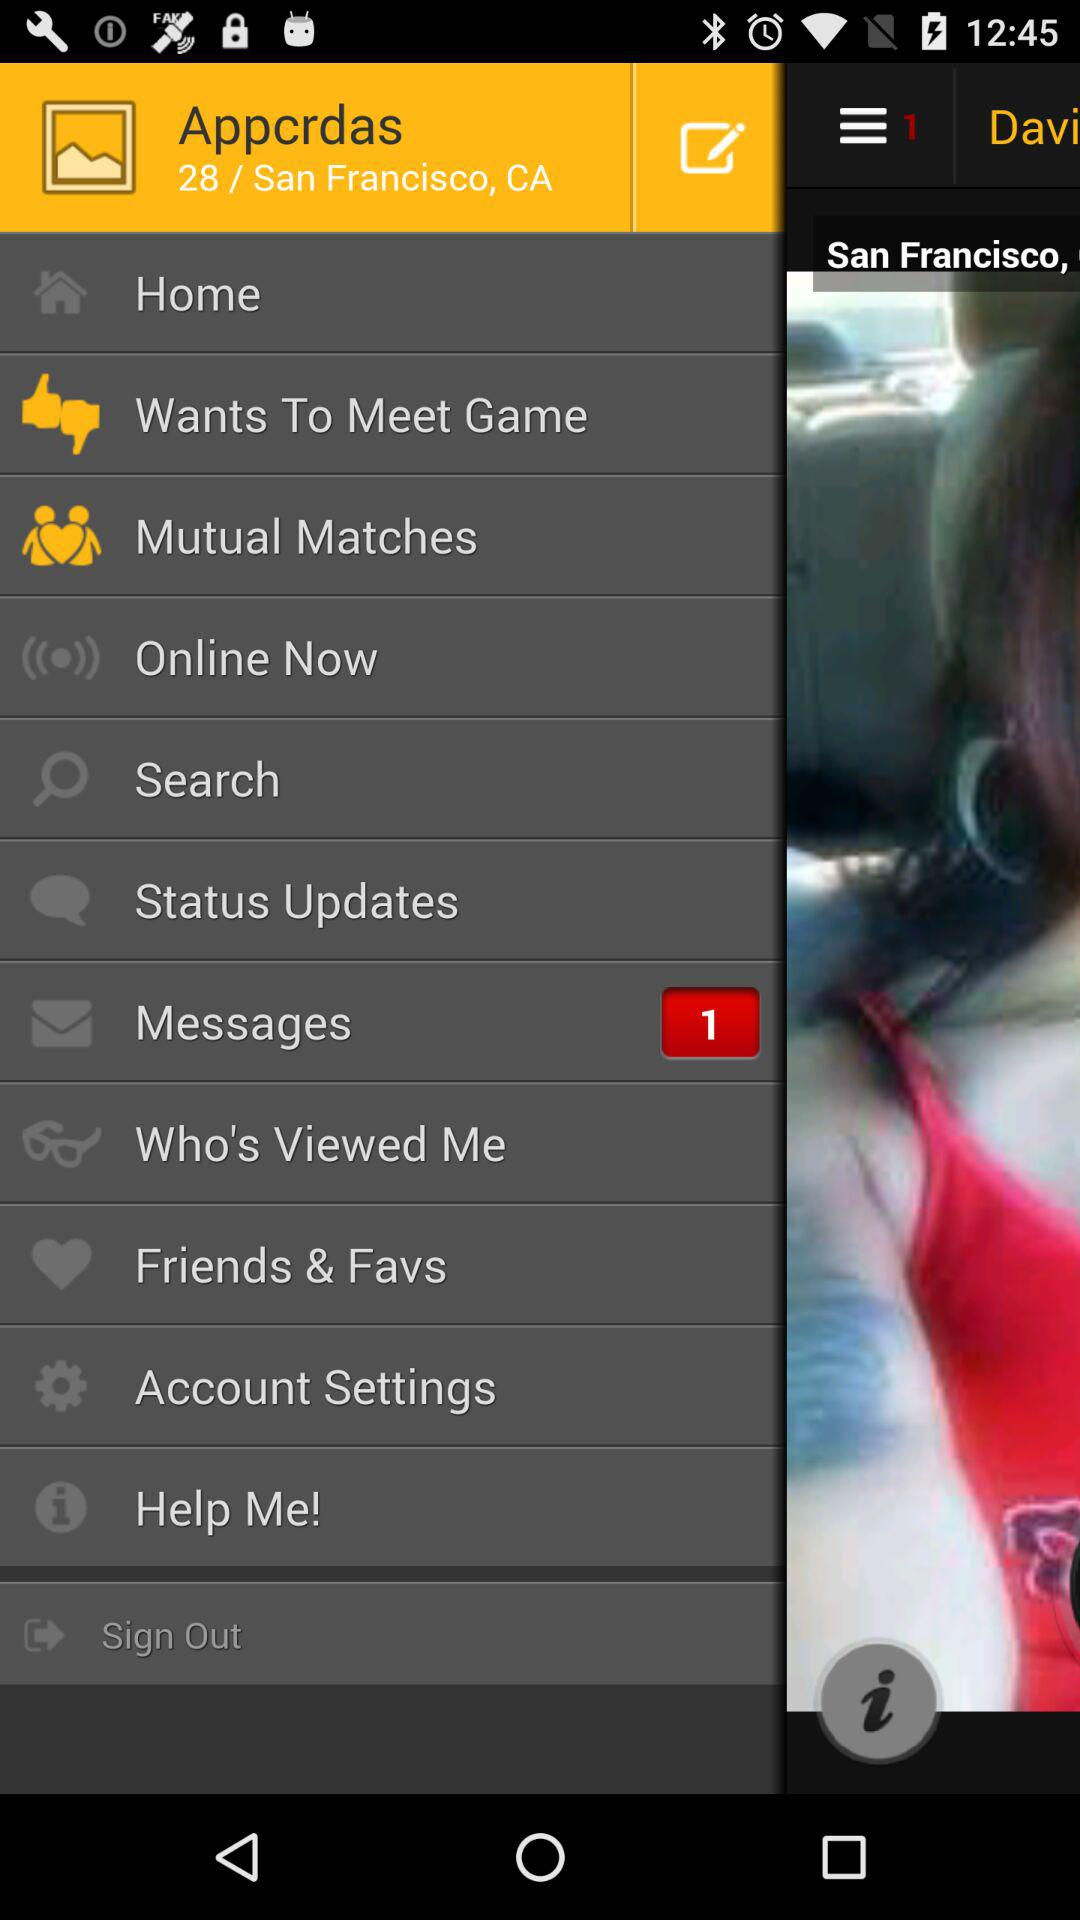Are there any unread messages? There is 1 unread message. 